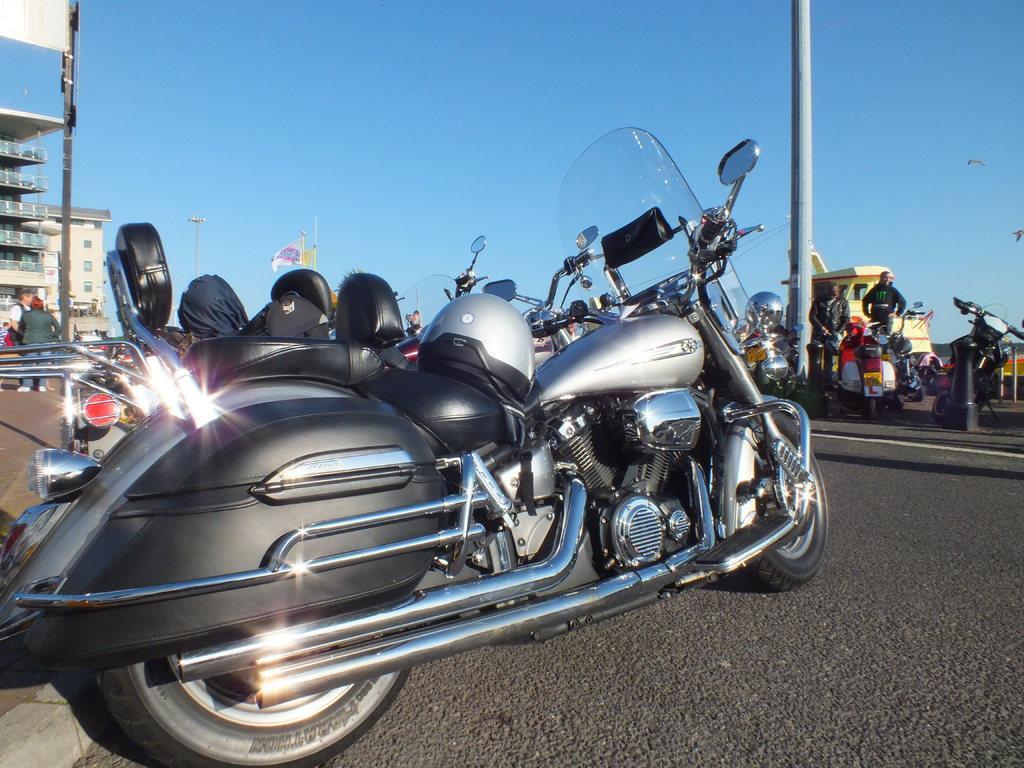Describe this image in one or two sentences. In this image we can see motorcycles. On that there is a helmet. On the left side there are few people standing. Also there are buildings and there is a pole. On the right side there are few people and there is a pillar. In the background there is sky. 